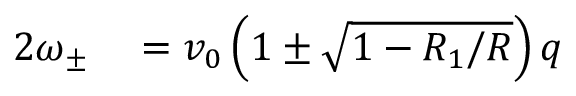Convert formula to latex. <formula><loc_0><loc_0><loc_500><loc_500>\begin{array} { r l } { 2 \omega _ { \pm } } & = v _ { 0 } \left ( 1 \pm \sqrt { 1 - R _ { 1 } / R } \right ) q } \end{array}</formula> 